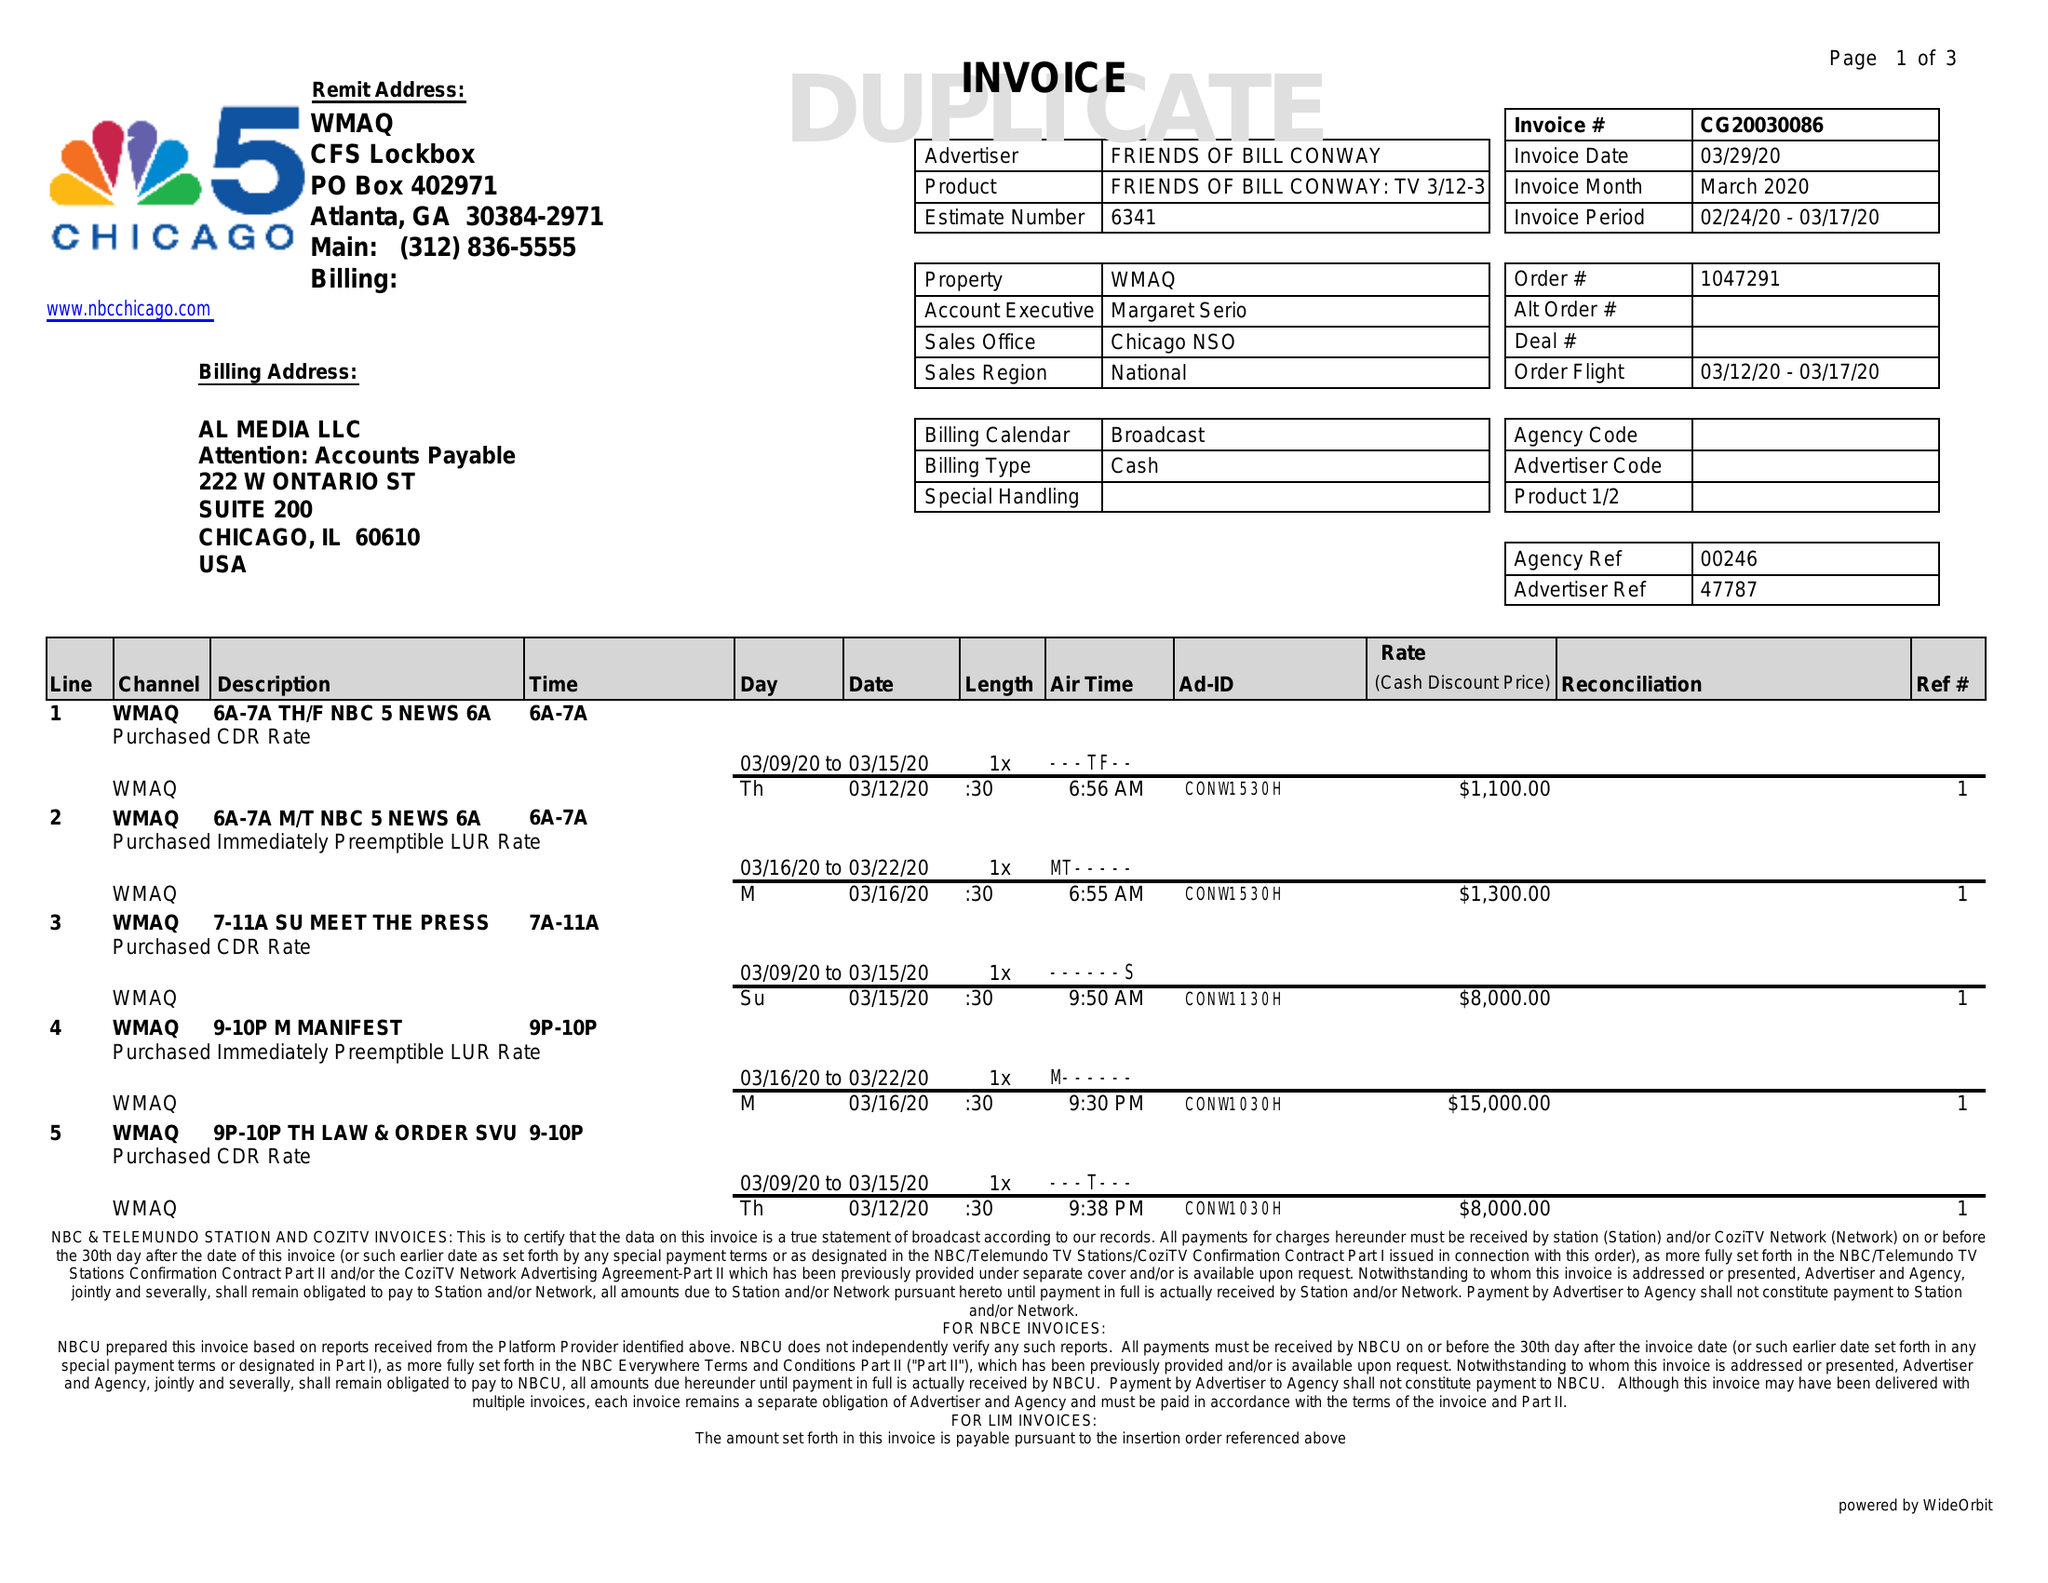What is the value for the advertiser?
Answer the question using a single word or phrase. FRIENDS OF BILL CONWAY 